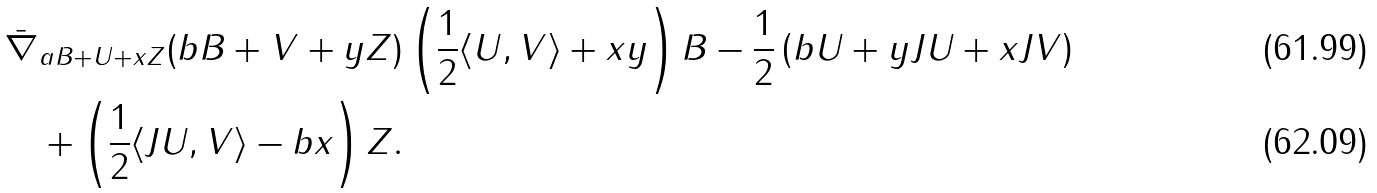Convert formula to latex. <formula><loc_0><loc_0><loc_500><loc_500>\bar { \nabla } _ { a B + U + x Z } ( b B + V + y Z ) & \left ( \frac { 1 } { 2 } \langle U , V \rangle + x y \right ) B - \frac { 1 } { 2 } \left ( b U + y J U + x J V \right ) \\ + \left ( \frac { 1 } { 2 } \langle J U , V \rangle - b x \right ) Z .</formula> 